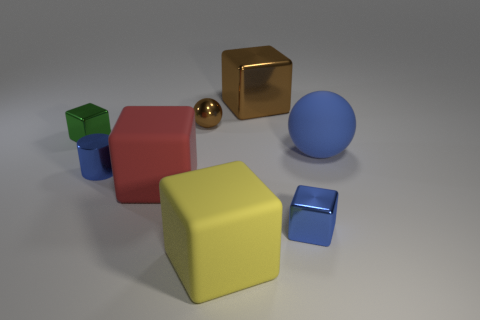Subtract all green cubes. How many cubes are left? 4 Subtract all brown shiny blocks. How many blocks are left? 4 Subtract all purple cubes. Subtract all blue balls. How many cubes are left? 5 Add 1 tiny shiny blocks. How many objects exist? 9 Subtract all cubes. How many objects are left? 3 Subtract all matte cylinders. Subtract all large brown shiny cubes. How many objects are left? 7 Add 8 big red matte cubes. How many big red matte cubes are left? 9 Add 4 big matte objects. How many big matte objects exist? 7 Subtract 1 yellow cubes. How many objects are left? 7 